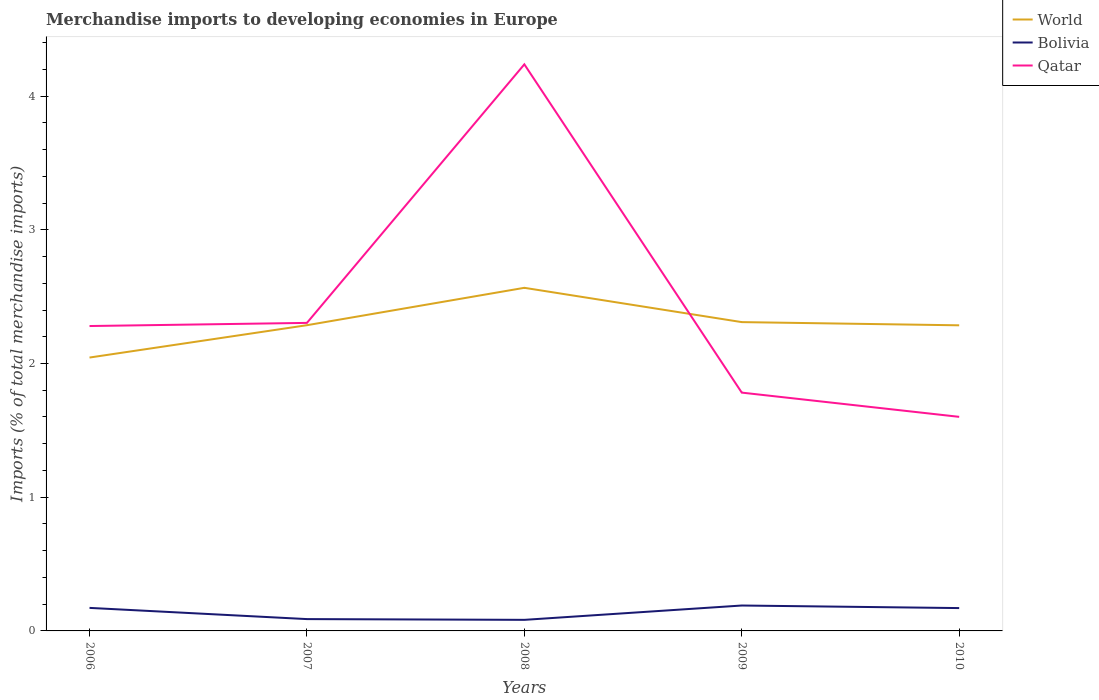Does the line corresponding to World intersect with the line corresponding to Qatar?
Your response must be concise. Yes. Across all years, what is the maximum percentage total merchandise imports in Qatar?
Provide a succinct answer. 1.6. In which year was the percentage total merchandise imports in Qatar maximum?
Offer a very short reply. 2010. What is the total percentage total merchandise imports in World in the graph?
Offer a terse response. 0.02. What is the difference between the highest and the second highest percentage total merchandise imports in World?
Offer a very short reply. 0.52. What is the difference between the highest and the lowest percentage total merchandise imports in Bolivia?
Your answer should be compact. 3. How many lines are there?
Offer a very short reply. 3. How many years are there in the graph?
Provide a succinct answer. 5. Does the graph contain grids?
Keep it short and to the point. No. Where does the legend appear in the graph?
Keep it short and to the point. Top right. How many legend labels are there?
Provide a short and direct response. 3. How are the legend labels stacked?
Offer a very short reply. Vertical. What is the title of the graph?
Ensure brevity in your answer.  Merchandise imports to developing economies in Europe. What is the label or title of the Y-axis?
Ensure brevity in your answer.  Imports (% of total merchandise imports). What is the Imports (% of total merchandise imports) in World in 2006?
Your response must be concise. 2.04. What is the Imports (% of total merchandise imports) in Bolivia in 2006?
Your response must be concise. 0.17. What is the Imports (% of total merchandise imports) in Qatar in 2006?
Your answer should be compact. 2.28. What is the Imports (% of total merchandise imports) in World in 2007?
Your answer should be very brief. 2.29. What is the Imports (% of total merchandise imports) in Bolivia in 2007?
Your answer should be compact. 0.09. What is the Imports (% of total merchandise imports) of Qatar in 2007?
Provide a short and direct response. 2.3. What is the Imports (% of total merchandise imports) in World in 2008?
Offer a very short reply. 2.57. What is the Imports (% of total merchandise imports) in Bolivia in 2008?
Provide a succinct answer. 0.08. What is the Imports (% of total merchandise imports) in Qatar in 2008?
Your answer should be compact. 4.24. What is the Imports (% of total merchandise imports) in World in 2009?
Your answer should be very brief. 2.31. What is the Imports (% of total merchandise imports) in Bolivia in 2009?
Provide a short and direct response. 0.19. What is the Imports (% of total merchandise imports) of Qatar in 2009?
Offer a very short reply. 1.78. What is the Imports (% of total merchandise imports) in World in 2010?
Give a very brief answer. 2.29. What is the Imports (% of total merchandise imports) in Bolivia in 2010?
Your answer should be very brief. 0.17. What is the Imports (% of total merchandise imports) of Qatar in 2010?
Provide a short and direct response. 1.6. Across all years, what is the maximum Imports (% of total merchandise imports) of World?
Ensure brevity in your answer.  2.57. Across all years, what is the maximum Imports (% of total merchandise imports) of Bolivia?
Give a very brief answer. 0.19. Across all years, what is the maximum Imports (% of total merchandise imports) of Qatar?
Make the answer very short. 4.24. Across all years, what is the minimum Imports (% of total merchandise imports) in World?
Offer a terse response. 2.04. Across all years, what is the minimum Imports (% of total merchandise imports) of Bolivia?
Give a very brief answer. 0.08. Across all years, what is the minimum Imports (% of total merchandise imports) in Qatar?
Your answer should be very brief. 1.6. What is the total Imports (% of total merchandise imports) of World in the graph?
Keep it short and to the point. 11.49. What is the total Imports (% of total merchandise imports) in Bolivia in the graph?
Ensure brevity in your answer.  0.7. What is the total Imports (% of total merchandise imports) in Qatar in the graph?
Provide a succinct answer. 12.2. What is the difference between the Imports (% of total merchandise imports) of World in 2006 and that in 2007?
Offer a very short reply. -0.24. What is the difference between the Imports (% of total merchandise imports) of Bolivia in 2006 and that in 2007?
Keep it short and to the point. 0.08. What is the difference between the Imports (% of total merchandise imports) in Qatar in 2006 and that in 2007?
Ensure brevity in your answer.  -0.02. What is the difference between the Imports (% of total merchandise imports) in World in 2006 and that in 2008?
Provide a succinct answer. -0.52. What is the difference between the Imports (% of total merchandise imports) in Bolivia in 2006 and that in 2008?
Provide a succinct answer. 0.09. What is the difference between the Imports (% of total merchandise imports) in Qatar in 2006 and that in 2008?
Provide a short and direct response. -1.96. What is the difference between the Imports (% of total merchandise imports) of World in 2006 and that in 2009?
Keep it short and to the point. -0.27. What is the difference between the Imports (% of total merchandise imports) of Bolivia in 2006 and that in 2009?
Keep it short and to the point. -0.02. What is the difference between the Imports (% of total merchandise imports) of Qatar in 2006 and that in 2009?
Your response must be concise. 0.5. What is the difference between the Imports (% of total merchandise imports) in World in 2006 and that in 2010?
Your answer should be very brief. -0.24. What is the difference between the Imports (% of total merchandise imports) of Bolivia in 2006 and that in 2010?
Ensure brevity in your answer.  0. What is the difference between the Imports (% of total merchandise imports) of Qatar in 2006 and that in 2010?
Your answer should be compact. 0.68. What is the difference between the Imports (% of total merchandise imports) of World in 2007 and that in 2008?
Ensure brevity in your answer.  -0.28. What is the difference between the Imports (% of total merchandise imports) of Bolivia in 2007 and that in 2008?
Make the answer very short. 0.01. What is the difference between the Imports (% of total merchandise imports) in Qatar in 2007 and that in 2008?
Your answer should be compact. -1.93. What is the difference between the Imports (% of total merchandise imports) in World in 2007 and that in 2009?
Offer a terse response. -0.02. What is the difference between the Imports (% of total merchandise imports) in Bolivia in 2007 and that in 2009?
Give a very brief answer. -0.1. What is the difference between the Imports (% of total merchandise imports) of Qatar in 2007 and that in 2009?
Make the answer very short. 0.52. What is the difference between the Imports (% of total merchandise imports) in World in 2007 and that in 2010?
Make the answer very short. 0. What is the difference between the Imports (% of total merchandise imports) of Bolivia in 2007 and that in 2010?
Your answer should be compact. -0.08. What is the difference between the Imports (% of total merchandise imports) of Qatar in 2007 and that in 2010?
Keep it short and to the point. 0.7. What is the difference between the Imports (% of total merchandise imports) in World in 2008 and that in 2009?
Give a very brief answer. 0.26. What is the difference between the Imports (% of total merchandise imports) of Bolivia in 2008 and that in 2009?
Your response must be concise. -0.11. What is the difference between the Imports (% of total merchandise imports) in Qatar in 2008 and that in 2009?
Offer a terse response. 2.46. What is the difference between the Imports (% of total merchandise imports) of World in 2008 and that in 2010?
Your answer should be compact. 0.28. What is the difference between the Imports (% of total merchandise imports) of Bolivia in 2008 and that in 2010?
Your answer should be very brief. -0.09. What is the difference between the Imports (% of total merchandise imports) of Qatar in 2008 and that in 2010?
Provide a short and direct response. 2.64. What is the difference between the Imports (% of total merchandise imports) in World in 2009 and that in 2010?
Your answer should be compact. 0.02. What is the difference between the Imports (% of total merchandise imports) in Bolivia in 2009 and that in 2010?
Make the answer very short. 0.02. What is the difference between the Imports (% of total merchandise imports) in Qatar in 2009 and that in 2010?
Give a very brief answer. 0.18. What is the difference between the Imports (% of total merchandise imports) of World in 2006 and the Imports (% of total merchandise imports) of Bolivia in 2007?
Offer a very short reply. 1.96. What is the difference between the Imports (% of total merchandise imports) of World in 2006 and the Imports (% of total merchandise imports) of Qatar in 2007?
Your response must be concise. -0.26. What is the difference between the Imports (% of total merchandise imports) in Bolivia in 2006 and the Imports (% of total merchandise imports) in Qatar in 2007?
Offer a terse response. -2.13. What is the difference between the Imports (% of total merchandise imports) in World in 2006 and the Imports (% of total merchandise imports) in Bolivia in 2008?
Make the answer very short. 1.96. What is the difference between the Imports (% of total merchandise imports) in World in 2006 and the Imports (% of total merchandise imports) in Qatar in 2008?
Your answer should be very brief. -2.19. What is the difference between the Imports (% of total merchandise imports) in Bolivia in 2006 and the Imports (% of total merchandise imports) in Qatar in 2008?
Ensure brevity in your answer.  -4.07. What is the difference between the Imports (% of total merchandise imports) of World in 2006 and the Imports (% of total merchandise imports) of Bolivia in 2009?
Make the answer very short. 1.85. What is the difference between the Imports (% of total merchandise imports) in World in 2006 and the Imports (% of total merchandise imports) in Qatar in 2009?
Provide a succinct answer. 0.26. What is the difference between the Imports (% of total merchandise imports) in Bolivia in 2006 and the Imports (% of total merchandise imports) in Qatar in 2009?
Offer a terse response. -1.61. What is the difference between the Imports (% of total merchandise imports) of World in 2006 and the Imports (% of total merchandise imports) of Bolivia in 2010?
Your response must be concise. 1.87. What is the difference between the Imports (% of total merchandise imports) of World in 2006 and the Imports (% of total merchandise imports) of Qatar in 2010?
Provide a short and direct response. 0.44. What is the difference between the Imports (% of total merchandise imports) of Bolivia in 2006 and the Imports (% of total merchandise imports) of Qatar in 2010?
Give a very brief answer. -1.43. What is the difference between the Imports (% of total merchandise imports) in World in 2007 and the Imports (% of total merchandise imports) in Bolivia in 2008?
Make the answer very short. 2.2. What is the difference between the Imports (% of total merchandise imports) of World in 2007 and the Imports (% of total merchandise imports) of Qatar in 2008?
Offer a very short reply. -1.95. What is the difference between the Imports (% of total merchandise imports) in Bolivia in 2007 and the Imports (% of total merchandise imports) in Qatar in 2008?
Offer a very short reply. -4.15. What is the difference between the Imports (% of total merchandise imports) in World in 2007 and the Imports (% of total merchandise imports) in Bolivia in 2009?
Your response must be concise. 2.1. What is the difference between the Imports (% of total merchandise imports) in World in 2007 and the Imports (% of total merchandise imports) in Qatar in 2009?
Give a very brief answer. 0.5. What is the difference between the Imports (% of total merchandise imports) of Bolivia in 2007 and the Imports (% of total merchandise imports) of Qatar in 2009?
Offer a terse response. -1.69. What is the difference between the Imports (% of total merchandise imports) of World in 2007 and the Imports (% of total merchandise imports) of Bolivia in 2010?
Your response must be concise. 2.12. What is the difference between the Imports (% of total merchandise imports) of World in 2007 and the Imports (% of total merchandise imports) of Qatar in 2010?
Make the answer very short. 0.69. What is the difference between the Imports (% of total merchandise imports) of Bolivia in 2007 and the Imports (% of total merchandise imports) of Qatar in 2010?
Your answer should be very brief. -1.51. What is the difference between the Imports (% of total merchandise imports) in World in 2008 and the Imports (% of total merchandise imports) in Bolivia in 2009?
Your answer should be compact. 2.38. What is the difference between the Imports (% of total merchandise imports) in World in 2008 and the Imports (% of total merchandise imports) in Qatar in 2009?
Offer a terse response. 0.78. What is the difference between the Imports (% of total merchandise imports) of Bolivia in 2008 and the Imports (% of total merchandise imports) of Qatar in 2009?
Ensure brevity in your answer.  -1.7. What is the difference between the Imports (% of total merchandise imports) of World in 2008 and the Imports (% of total merchandise imports) of Bolivia in 2010?
Ensure brevity in your answer.  2.4. What is the difference between the Imports (% of total merchandise imports) of Bolivia in 2008 and the Imports (% of total merchandise imports) of Qatar in 2010?
Ensure brevity in your answer.  -1.52. What is the difference between the Imports (% of total merchandise imports) of World in 2009 and the Imports (% of total merchandise imports) of Bolivia in 2010?
Give a very brief answer. 2.14. What is the difference between the Imports (% of total merchandise imports) of World in 2009 and the Imports (% of total merchandise imports) of Qatar in 2010?
Provide a short and direct response. 0.71. What is the difference between the Imports (% of total merchandise imports) in Bolivia in 2009 and the Imports (% of total merchandise imports) in Qatar in 2010?
Your answer should be compact. -1.41. What is the average Imports (% of total merchandise imports) in World per year?
Your answer should be compact. 2.3. What is the average Imports (% of total merchandise imports) in Bolivia per year?
Your answer should be very brief. 0.14. What is the average Imports (% of total merchandise imports) of Qatar per year?
Your answer should be very brief. 2.44. In the year 2006, what is the difference between the Imports (% of total merchandise imports) of World and Imports (% of total merchandise imports) of Bolivia?
Keep it short and to the point. 1.87. In the year 2006, what is the difference between the Imports (% of total merchandise imports) in World and Imports (% of total merchandise imports) in Qatar?
Ensure brevity in your answer.  -0.24. In the year 2006, what is the difference between the Imports (% of total merchandise imports) in Bolivia and Imports (% of total merchandise imports) in Qatar?
Make the answer very short. -2.11. In the year 2007, what is the difference between the Imports (% of total merchandise imports) of World and Imports (% of total merchandise imports) of Bolivia?
Keep it short and to the point. 2.2. In the year 2007, what is the difference between the Imports (% of total merchandise imports) of World and Imports (% of total merchandise imports) of Qatar?
Offer a very short reply. -0.02. In the year 2007, what is the difference between the Imports (% of total merchandise imports) of Bolivia and Imports (% of total merchandise imports) of Qatar?
Provide a short and direct response. -2.22. In the year 2008, what is the difference between the Imports (% of total merchandise imports) of World and Imports (% of total merchandise imports) of Bolivia?
Your answer should be very brief. 2.48. In the year 2008, what is the difference between the Imports (% of total merchandise imports) in World and Imports (% of total merchandise imports) in Qatar?
Keep it short and to the point. -1.67. In the year 2008, what is the difference between the Imports (% of total merchandise imports) of Bolivia and Imports (% of total merchandise imports) of Qatar?
Offer a terse response. -4.15. In the year 2009, what is the difference between the Imports (% of total merchandise imports) in World and Imports (% of total merchandise imports) in Bolivia?
Your response must be concise. 2.12. In the year 2009, what is the difference between the Imports (% of total merchandise imports) of World and Imports (% of total merchandise imports) of Qatar?
Ensure brevity in your answer.  0.53. In the year 2009, what is the difference between the Imports (% of total merchandise imports) of Bolivia and Imports (% of total merchandise imports) of Qatar?
Offer a terse response. -1.59. In the year 2010, what is the difference between the Imports (% of total merchandise imports) of World and Imports (% of total merchandise imports) of Bolivia?
Your answer should be compact. 2.11. In the year 2010, what is the difference between the Imports (% of total merchandise imports) of World and Imports (% of total merchandise imports) of Qatar?
Your response must be concise. 0.68. In the year 2010, what is the difference between the Imports (% of total merchandise imports) in Bolivia and Imports (% of total merchandise imports) in Qatar?
Make the answer very short. -1.43. What is the ratio of the Imports (% of total merchandise imports) in World in 2006 to that in 2007?
Your response must be concise. 0.89. What is the ratio of the Imports (% of total merchandise imports) in Bolivia in 2006 to that in 2007?
Provide a short and direct response. 1.95. What is the ratio of the Imports (% of total merchandise imports) in World in 2006 to that in 2008?
Offer a very short reply. 0.8. What is the ratio of the Imports (% of total merchandise imports) in Bolivia in 2006 to that in 2008?
Ensure brevity in your answer.  2.08. What is the ratio of the Imports (% of total merchandise imports) in Qatar in 2006 to that in 2008?
Your answer should be very brief. 0.54. What is the ratio of the Imports (% of total merchandise imports) of World in 2006 to that in 2009?
Keep it short and to the point. 0.89. What is the ratio of the Imports (% of total merchandise imports) of Bolivia in 2006 to that in 2009?
Make the answer very short. 0.91. What is the ratio of the Imports (% of total merchandise imports) in Qatar in 2006 to that in 2009?
Your answer should be very brief. 1.28. What is the ratio of the Imports (% of total merchandise imports) of World in 2006 to that in 2010?
Your answer should be compact. 0.89. What is the ratio of the Imports (% of total merchandise imports) in Bolivia in 2006 to that in 2010?
Your answer should be very brief. 1.01. What is the ratio of the Imports (% of total merchandise imports) of Qatar in 2006 to that in 2010?
Your response must be concise. 1.42. What is the ratio of the Imports (% of total merchandise imports) of World in 2007 to that in 2008?
Your answer should be very brief. 0.89. What is the ratio of the Imports (% of total merchandise imports) of Bolivia in 2007 to that in 2008?
Provide a succinct answer. 1.07. What is the ratio of the Imports (% of total merchandise imports) in Qatar in 2007 to that in 2008?
Your answer should be very brief. 0.54. What is the ratio of the Imports (% of total merchandise imports) in World in 2007 to that in 2009?
Offer a terse response. 0.99. What is the ratio of the Imports (% of total merchandise imports) in Bolivia in 2007 to that in 2009?
Make the answer very short. 0.47. What is the ratio of the Imports (% of total merchandise imports) in Qatar in 2007 to that in 2009?
Provide a succinct answer. 1.29. What is the ratio of the Imports (% of total merchandise imports) in Bolivia in 2007 to that in 2010?
Offer a terse response. 0.52. What is the ratio of the Imports (% of total merchandise imports) of Qatar in 2007 to that in 2010?
Your response must be concise. 1.44. What is the ratio of the Imports (% of total merchandise imports) in World in 2008 to that in 2009?
Provide a succinct answer. 1.11. What is the ratio of the Imports (% of total merchandise imports) of Bolivia in 2008 to that in 2009?
Offer a very short reply. 0.44. What is the ratio of the Imports (% of total merchandise imports) in Qatar in 2008 to that in 2009?
Make the answer very short. 2.38. What is the ratio of the Imports (% of total merchandise imports) in World in 2008 to that in 2010?
Make the answer very short. 1.12. What is the ratio of the Imports (% of total merchandise imports) in Bolivia in 2008 to that in 2010?
Offer a very short reply. 0.48. What is the ratio of the Imports (% of total merchandise imports) in Qatar in 2008 to that in 2010?
Your answer should be very brief. 2.65. What is the ratio of the Imports (% of total merchandise imports) of World in 2009 to that in 2010?
Make the answer very short. 1.01. What is the ratio of the Imports (% of total merchandise imports) in Bolivia in 2009 to that in 2010?
Make the answer very short. 1.11. What is the ratio of the Imports (% of total merchandise imports) in Qatar in 2009 to that in 2010?
Your answer should be very brief. 1.11. What is the difference between the highest and the second highest Imports (% of total merchandise imports) of World?
Your answer should be very brief. 0.26. What is the difference between the highest and the second highest Imports (% of total merchandise imports) of Bolivia?
Provide a succinct answer. 0.02. What is the difference between the highest and the second highest Imports (% of total merchandise imports) of Qatar?
Provide a succinct answer. 1.93. What is the difference between the highest and the lowest Imports (% of total merchandise imports) of World?
Give a very brief answer. 0.52. What is the difference between the highest and the lowest Imports (% of total merchandise imports) in Bolivia?
Give a very brief answer. 0.11. What is the difference between the highest and the lowest Imports (% of total merchandise imports) in Qatar?
Offer a very short reply. 2.64. 